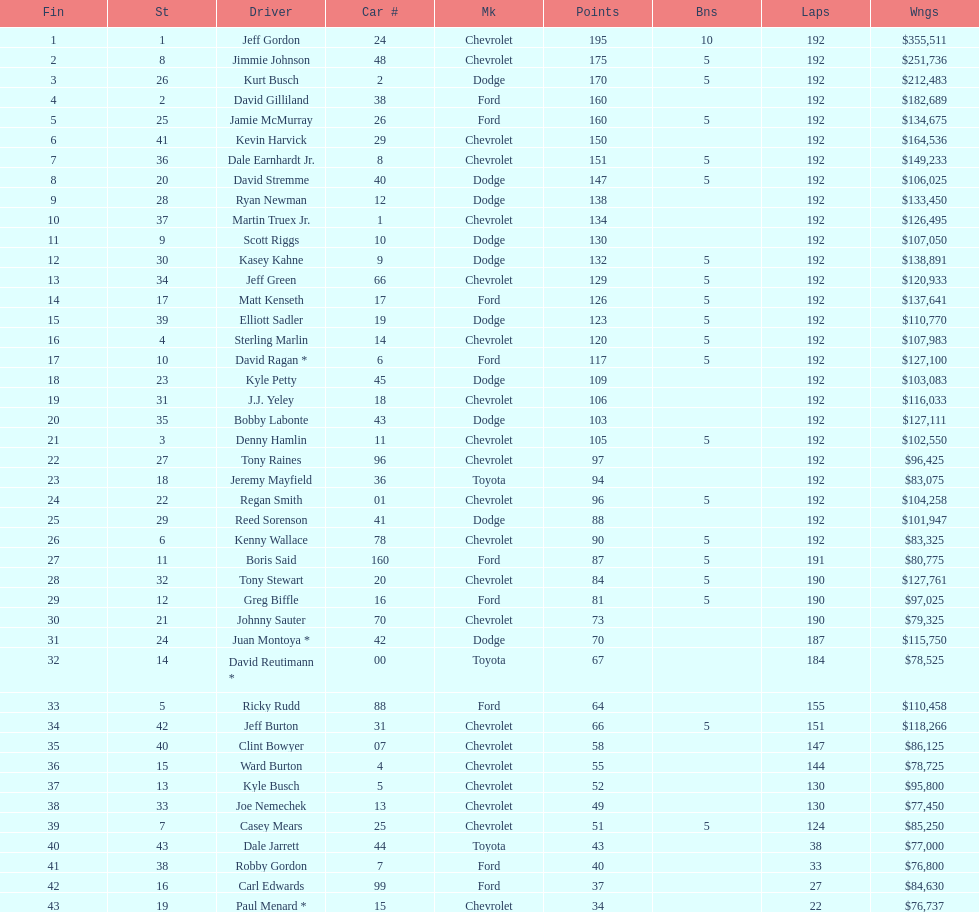How many drivers placed below tony stewart? 15. 